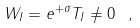<formula> <loc_0><loc_0><loc_500><loc_500>W _ { I } = e ^ { + \sigma } T _ { I } \neq 0 \text { } ,</formula> 